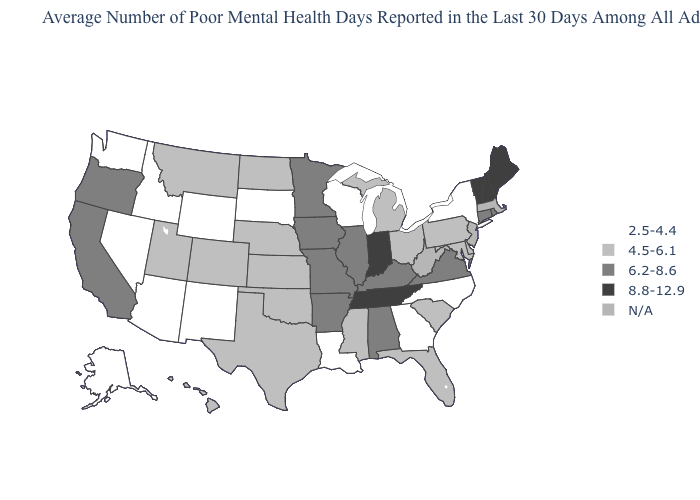Name the states that have a value in the range 6.2-8.6?
Give a very brief answer. Alabama, Arkansas, California, Connecticut, Illinois, Iowa, Kentucky, Minnesota, Missouri, Oregon, Rhode Island, Virginia. Name the states that have a value in the range N/A?
Quick response, please. Massachusetts, New Jersey, West Virginia. Name the states that have a value in the range 4.5-6.1?
Be succinct. Colorado, Delaware, Florida, Hawaii, Kansas, Maryland, Michigan, Mississippi, Montana, Nebraska, North Dakota, Ohio, Oklahoma, Pennsylvania, South Carolina, Texas, Utah. What is the highest value in states that border North Dakota?
Be succinct. 6.2-8.6. What is the value of Montana?
Write a very short answer. 4.5-6.1. What is the value of Illinois?
Keep it brief. 6.2-8.6. Does New Mexico have the highest value in the USA?
Be succinct. No. Does the first symbol in the legend represent the smallest category?
Short answer required. Yes. Name the states that have a value in the range 8.8-12.9?
Concise answer only. Indiana, Maine, New Hampshire, Tennessee, Vermont. What is the value of South Dakota?
Give a very brief answer. 2.5-4.4. Name the states that have a value in the range 2.5-4.4?
Answer briefly. Alaska, Arizona, Georgia, Idaho, Louisiana, Nevada, New Mexico, New York, North Carolina, South Dakota, Washington, Wisconsin, Wyoming. What is the highest value in states that border Wyoming?
Give a very brief answer. 4.5-6.1. Does Tennessee have the highest value in the South?
Keep it brief. Yes. What is the lowest value in states that border Colorado?
Keep it brief. 2.5-4.4. 